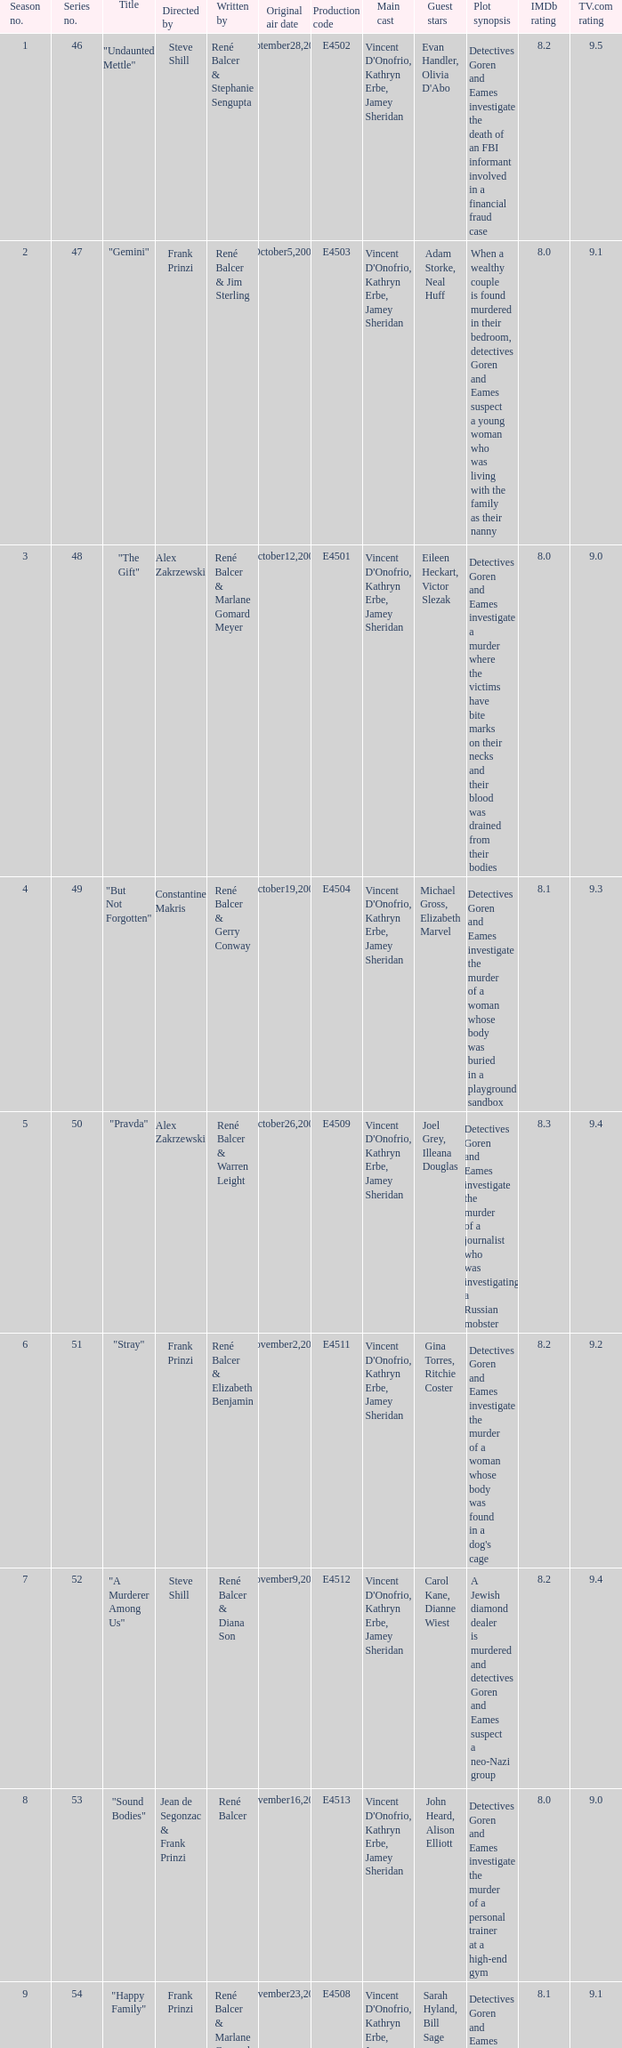Who wrote the episode with e4515 as the production code? René Balcer & Elizabeth Benjamin. 